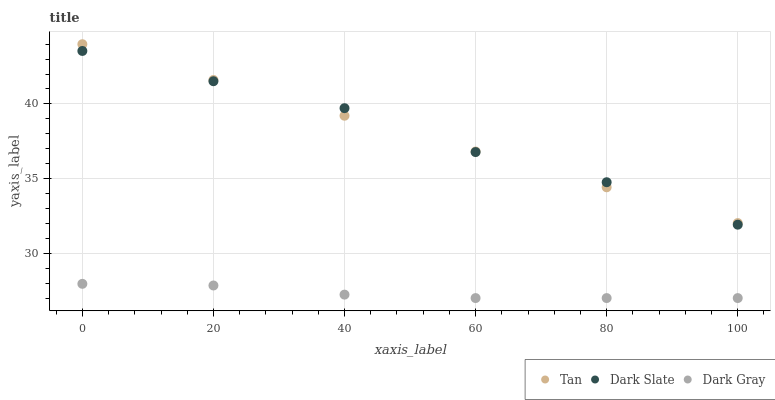Does Dark Gray have the minimum area under the curve?
Answer yes or no. Yes. Does Dark Slate have the maximum area under the curve?
Answer yes or no. Yes. Does Tan have the minimum area under the curve?
Answer yes or no. No. Does Tan have the maximum area under the curve?
Answer yes or no. No. Is Tan the smoothest?
Answer yes or no. Yes. Is Dark Slate the roughest?
Answer yes or no. Yes. Is Dark Slate the smoothest?
Answer yes or no. No. Is Tan the roughest?
Answer yes or no. No. Does Dark Gray have the lowest value?
Answer yes or no. Yes. Does Dark Slate have the lowest value?
Answer yes or no. No. Does Tan have the highest value?
Answer yes or no. Yes. Does Dark Slate have the highest value?
Answer yes or no. No. Is Dark Gray less than Tan?
Answer yes or no. Yes. Is Dark Slate greater than Dark Gray?
Answer yes or no. Yes. Does Dark Slate intersect Tan?
Answer yes or no. Yes. Is Dark Slate less than Tan?
Answer yes or no. No. Is Dark Slate greater than Tan?
Answer yes or no. No. Does Dark Gray intersect Tan?
Answer yes or no. No. 